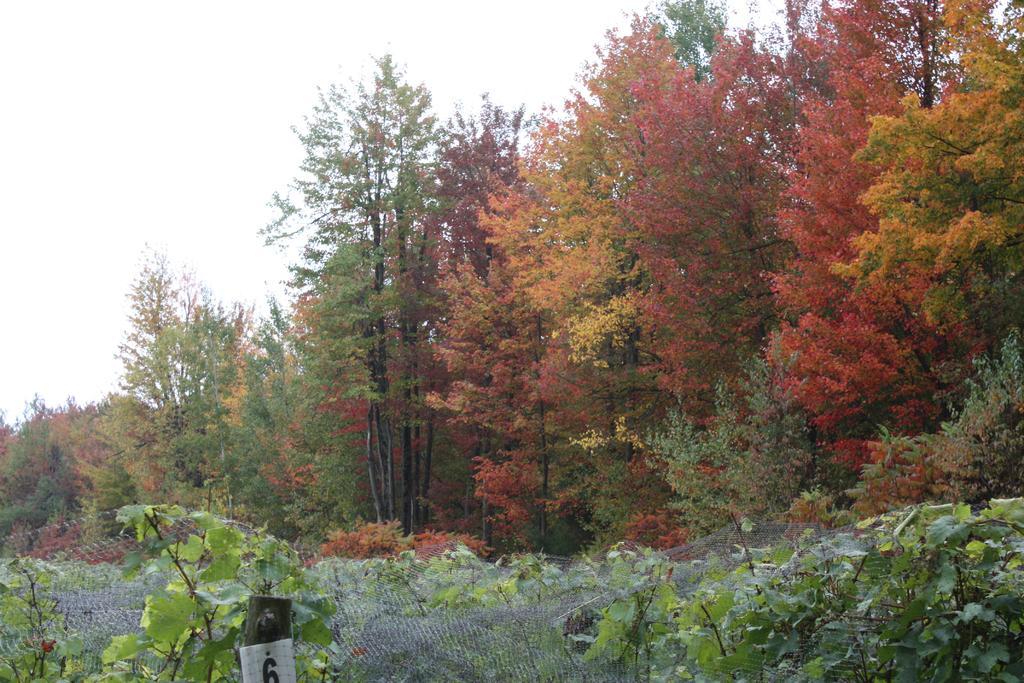In one or two sentences, can you explain what this image depicts? In this image we can see some trees, plants, net and top of the image there is clear sky. 